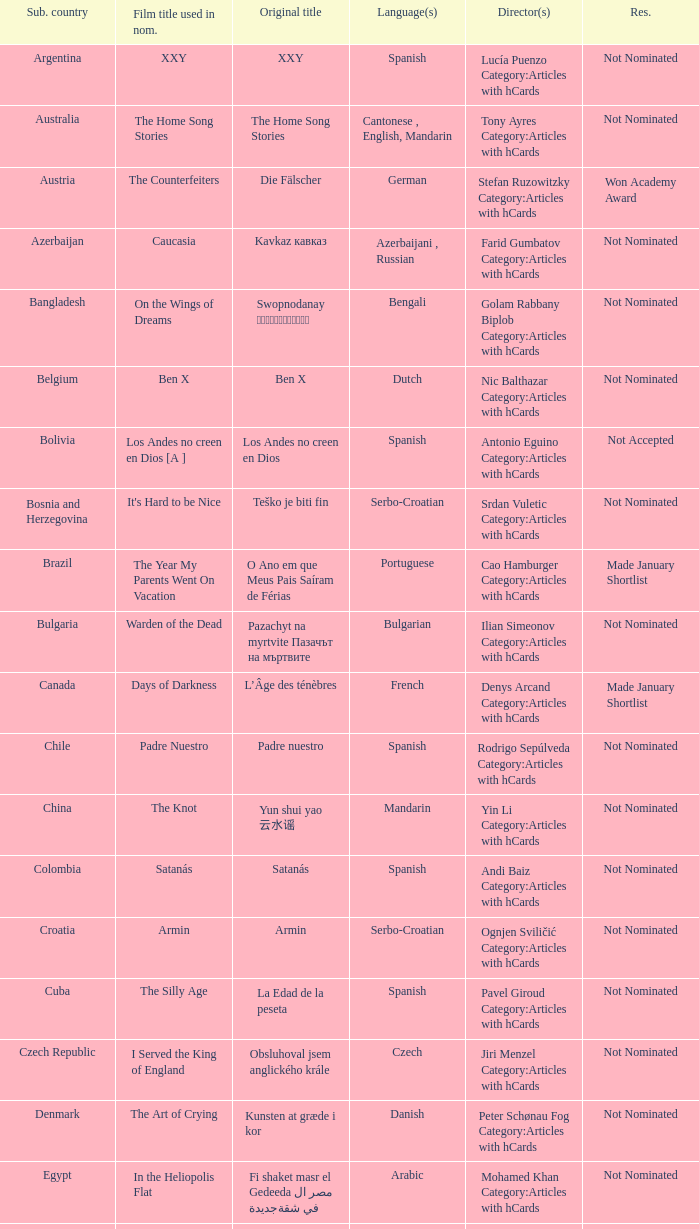What was the title of the movie from lebanon? Caramel. Can you give me this table as a dict? {'header': ['Sub. country', 'Film title used in nom.', 'Original title', 'Language(s)', 'Director(s)', 'Res.'], 'rows': [['Argentina', 'XXY', 'XXY', 'Spanish', 'Lucía Puenzo Category:Articles with hCards', 'Not Nominated'], ['Australia', 'The Home Song Stories', 'The Home Song Stories', 'Cantonese , English, Mandarin', 'Tony Ayres Category:Articles with hCards', 'Not Nominated'], ['Austria', 'The Counterfeiters', 'Die Fälscher', 'German', 'Stefan Ruzowitzky Category:Articles with hCards', 'Won Academy Award'], ['Azerbaijan', 'Caucasia', 'Kavkaz кавказ', 'Azerbaijani , Russian', 'Farid Gumbatov Category:Articles with hCards', 'Not Nominated'], ['Bangladesh', 'On the Wings of Dreams', 'Swopnodanay স্বপ্নডানায়', 'Bengali', 'Golam Rabbany Biplob Category:Articles with hCards', 'Not Nominated'], ['Belgium', 'Ben X', 'Ben X', 'Dutch', 'Nic Balthazar Category:Articles with hCards', 'Not Nominated'], ['Bolivia', 'Los Andes no creen en Dios [A ]', 'Los Andes no creen en Dios', 'Spanish', 'Antonio Eguino Category:Articles with hCards', 'Not Accepted'], ['Bosnia and Herzegovina', "It's Hard to be Nice", 'Teško je biti fin', 'Serbo-Croatian', 'Srdan Vuletic Category:Articles with hCards', 'Not Nominated'], ['Brazil', 'The Year My Parents Went On Vacation', 'O Ano em que Meus Pais Saíram de Férias', 'Portuguese', 'Cao Hamburger Category:Articles with hCards', 'Made January Shortlist'], ['Bulgaria', 'Warden of the Dead', 'Pazachyt na myrtvite Пазачът на мъртвите', 'Bulgarian', 'Ilian Simeonov Category:Articles with hCards', 'Not Nominated'], ['Canada', 'Days of Darkness', 'L’Âge des ténèbres', 'French', 'Denys Arcand Category:Articles with hCards', 'Made January Shortlist'], ['Chile', 'Padre Nuestro', 'Padre nuestro', 'Spanish', 'Rodrigo Sepúlveda Category:Articles with hCards', 'Not Nominated'], ['China', 'The Knot', 'Yun shui yao 云水谣', 'Mandarin', 'Yin Li Category:Articles with hCards', 'Not Nominated'], ['Colombia', 'Satanás', 'Satanás', 'Spanish', 'Andi Baiz Category:Articles with hCards', 'Not Nominated'], ['Croatia', 'Armin', 'Armin', 'Serbo-Croatian', 'Ognjen Sviličić Category:Articles with hCards', 'Not Nominated'], ['Cuba', 'The Silly Age', 'La Edad de la peseta', 'Spanish', 'Pavel Giroud Category:Articles with hCards', 'Not Nominated'], ['Czech Republic', 'I Served the King of England', 'Obsluhoval jsem anglického krále', 'Czech', 'Jiri Menzel Category:Articles with hCards', 'Not Nominated'], ['Denmark', 'The Art of Crying', 'Kunsten at græde i kor', 'Danish', 'Peter Schønau Fog Category:Articles with hCards', 'Not Nominated'], ['Egypt', 'In the Heliopolis Flat', 'Fi shaket masr el Gedeeda في شقة مصر الجديدة', 'Arabic', 'Mohamed Khan Category:Articles with hCards', 'Not Nominated'], ['Estonia', 'The Class', 'Klass', 'Estonian', 'Ilmar Raag Category:Articles with hCards', 'Not Nominated'], ['Finland', "A Man's Job", 'Miehen työ', 'Finnish', 'Aleksi Salmenperä Category:Articles with hCards', 'Not Nominated'], ['Georgia', 'The Russian Triangle', 'Rusuli samkudhedi Русский треугольник', 'Russian', 'Aleko Tsabadze Category:Articles with hCards', 'Not Nominated'], ['Germany', 'The Edge of Heaven', 'Auf der anderen Seite', 'German, Turkish', 'Fatih Akin Category:Articles with hCards', 'Not Nominated'], ['Greece', 'Eduart', 'Eduart', 'Albanian , German, Greek', 'Angeliki Antoniou Category:Articles with hCards', 'Not Nominated'], ['Hong Kong', 'Exiled', 'Fong juk 放逐', 'Cantonese', 'Johnnie To Category:Articles with hCards', 'Not Nominated'], ['Hungary', 'Taxidermia', 'Taxidermia', 'Hungarian', 'György Pálfi Category:Articles with hCards', 'Not Nominated'], ['Iceland', 'Jar City', 'Mýrin', 'Icelandic', 'Baltasar Kormakur Category:Articles with hCards', 'Not Nominated'], ['India', 'Eklavya: The Royal Guard [B ]', 'Eklavya: The Royal Guard एकलव्य', 'Hindi', 'Vidhu Vinod Chopra Category:Articles with hCards', 'Not Nominated'], ['Indonesia', 'Denias, Singing on the Cloud', 'Denias Senandung Di Atas Awan', 'Indonesian', 'John De Rantau Category:Articles with hCards', 'Not Nominated'], ['Iran', 'M for Mother', 'Mim Mesle Madar میم مثل مادر', 'Persian', 'Rasul Mollagholipour Category:Articles with hCards', 'Not Nominated'], ['Iraq', 'Jani Gal', 'Jani Gal', 'Kurdish', 'Jamil Rostami Category:Articles with hCards', 'Not Nominated'], ['Ireland', 'Kings', 'Kings', 'Irish, English', 'Tommy Collins Category:Articles with hCards', 'Not Nominated'], ['Israel', 'Beaufort [C ]', 'Beaufort בופור', 'Hebrew', 'Joseph Cedar Category:Articles with hCards', 'Nominee'], ['Italy', 'La sconosciuta', 'La sconosciuta', 'Italian', 'Giuseppe Tornatore Category:Articles with hCards', 'Made January Shortlist'], ['Japan', "I Just Didn't Do It", 'Soredemo boku wa yatte nai ( それでもボクはやってない ? )', 'Japanese', 'Masayuki Suo Category:Articles with hCards', 'Not Nominated'], ['Kazakhstan', 'Mongol', 'Mongol Монгол', 'Mongolian', 'Sergei Bodrov Category:Articles with hCards', 'Nominee'], ['Lebanon', 'Caramel', 'Sukkar banat سكر بنات', 'Arabic, French', 'Nadine Labaki Category:Articles with hCards', 'Not Nominated'], ['Luxembourg', 'Little Secrets', 'Perl oder Pica', 'Luxembourgish', 'Pol Cruchten Category:Articles with hCards', 'Not Nominated'], ['Macedonia', 'Shadows', 'Senki Сенки', 'Macedonian', 'Milčo Mančevski Category:Articles with hCards', 'Not Nominated'], ['Mexico', 'Silent Light', 'Stellet licht', 'Plautdietsch', 'Carlos Reygadas Category:Articles with hCards', 'Not Nominated'], ['Netherlands', 'Duska', 'Duska', 'Dutch', 'Jos Stelling Category:Articles with hCards', 'Not Nominated'], ['Norway', 'Gone with the Woman', 'Tatt av Kvinnen', 'Norwegian', 'Petter Naess Category:Articles with hCards', 'Not Nominated'], ['Peru', 'Crossing a Shadow', 'Una sombra al frente', 'Spanish', 'Augusto Tamayo Category:Articles with hCards', 'Not Nominated'], ['Philippines', 'Donsol', 'Donsol', 'Bikol , Tagalog', 'Adolfo Alix, Jr. Category:Articles with hCards', 'Not Nominated'], ['Poland', 'Katyń', 'Katyń', 'Polish', 'Andrzej Wajda Category:Articles with hCards', 'Nominee'], ['Portugal', 'Belle Toujours', 'Belle Toujours', 'French', 'Manoel de Oliveira Category:Articles with hCards', 'Not Nominated'], ['Romania', '4 Months, 3 Weeks and 2 Days', '4 luni, 3 săptămâni şi 2 zile', 'Romanian', 'Cristian Mungiu Category:Articles with hCards', 'Not Nominated'], ['Russia', '12', '12', 'Russian, Chechen', 'Nikita Mikhalkov Category:Articles with hCards', 'Nominee'], ['Serbia', 'The Trap', 'Klopka Клопка', 'Serbo-Croatian', 'Srdan Golubović Category:Articles with hCards', 'Made January Shortlist'], ['Singapore', '881', '881', 'Mandarin , Hokkien', 'Royston Tan Category:Articles with hCards', 'Not Nominated'], ['Slovakia', 'Return of the Storks', 'Návrat bocianov', 'German , Slovak', 'Martin Repka Category:Articles with hCards', 'Not Nominated'], ['Slovenia', 'Short Circuits', 'Kratki stiki', 'Slovene', 'Janez Lapajne Category:Articles with hCards', 'Not Nominated'], ['South Korea', 'Secret Sunshine', 'Milyang 밀양', 'Korean', 'Lee Chang-dong Category:Articles with hCards', 'Not Nominated'], ['Spain', 'The Orphanage', 'El orfanato', 'Spanish', 'Juan Antonio Bayona Category:Articles with hCards', 'Not Nominated'], ['Sweden', 'You, the Living', 'Du levande', 'Swedish', 'Roy Andersson Category:Articles with hCards', 'Not Nominated'], ['Switzerland', 'Late Bloomers', 'Die Herbstzeitlosen', 'Swiss German', 'Bettina Oberli Category:Articles with hCards', 'Not Nominated'], ['Taiwan', 'Island Etude [D ]', 'Liànxí Qǔ 練習曲', 'Mandarin , Taiwanese', 'Chen Huai-En Category:Articles with hCards', 'Not Nominated'], ['Turkey', "A Man's Fear of God", 'Takva', 'Turkish', 'Özer Kızıltan Category:Articles with hCards', 'Not Nominated'], ['Venezuela', 'Postcards from Leningrad', 'Postales de Leningrado', 'Spanish', 'Mariana Rondon Category:Articles with hCards', 'Not Nominated']]} 